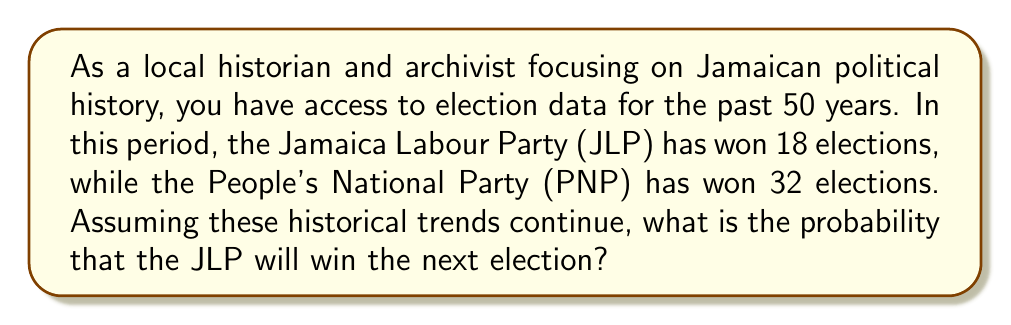Give your solution to this math problem. To solve this problem, we'll use the concept of relative frequency as an estimate of probability. Here's the step-by-step solution:

1. Identify the total number of elections:
   $n_{total} = 18 + 32 = 50$

2. Identify the number of JLP wins:
   $n_{JLP} = 18$

3. Calculate the probability using the relative frequency formula:
   $$P(JLP \text{ win}) = \frac{n_{JLP}}{n_{total}} = \frac{18}{50}$$

4. Simplify the fraction:
   $$P(JLP \text{ win}) = \frac{18}{50} = \frac{9}{25} = 0.36$$

5. Convert to a percentage:
   $$P(JLP \text{ win}) = 0.36 \times 100\% = 36\%$$

Therefore, based on the historical data, the probability of the Jamaica Labour Party winning the next election is 36% or 0.36.
Answer: $0.36$ or $36\%$ 